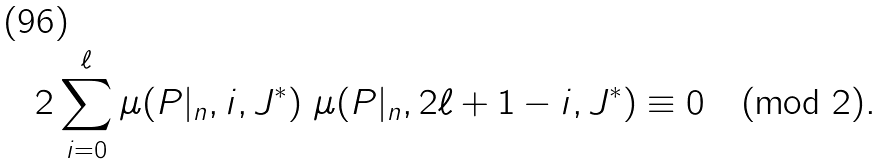Convert formula to latex. <formula><loc_0><loc_0><loc_500><loc_500>2 \sum _ { i = 0 } ^ { \ell } \mu ( P | _ { n } , i , J ^ { \ast } ) \ \mu ( P | _ { n } , 2 \ell + 1 - i , J ^ { \ast } ) \equiv 0 \pmod { 2 } .</formula> 